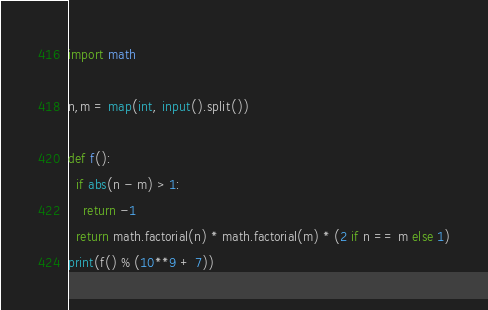<code> <loc_0><loc_0><loc_500><loc_500><_Python_>import math

n,m = map(int, input().split())

def f():
  if abs(n - m) > 1:
    return -1
  return math.factorial(n) * math.factorial(m) * (2 if n == m else 1)
print(f() % (10**9 + 7))</code> 